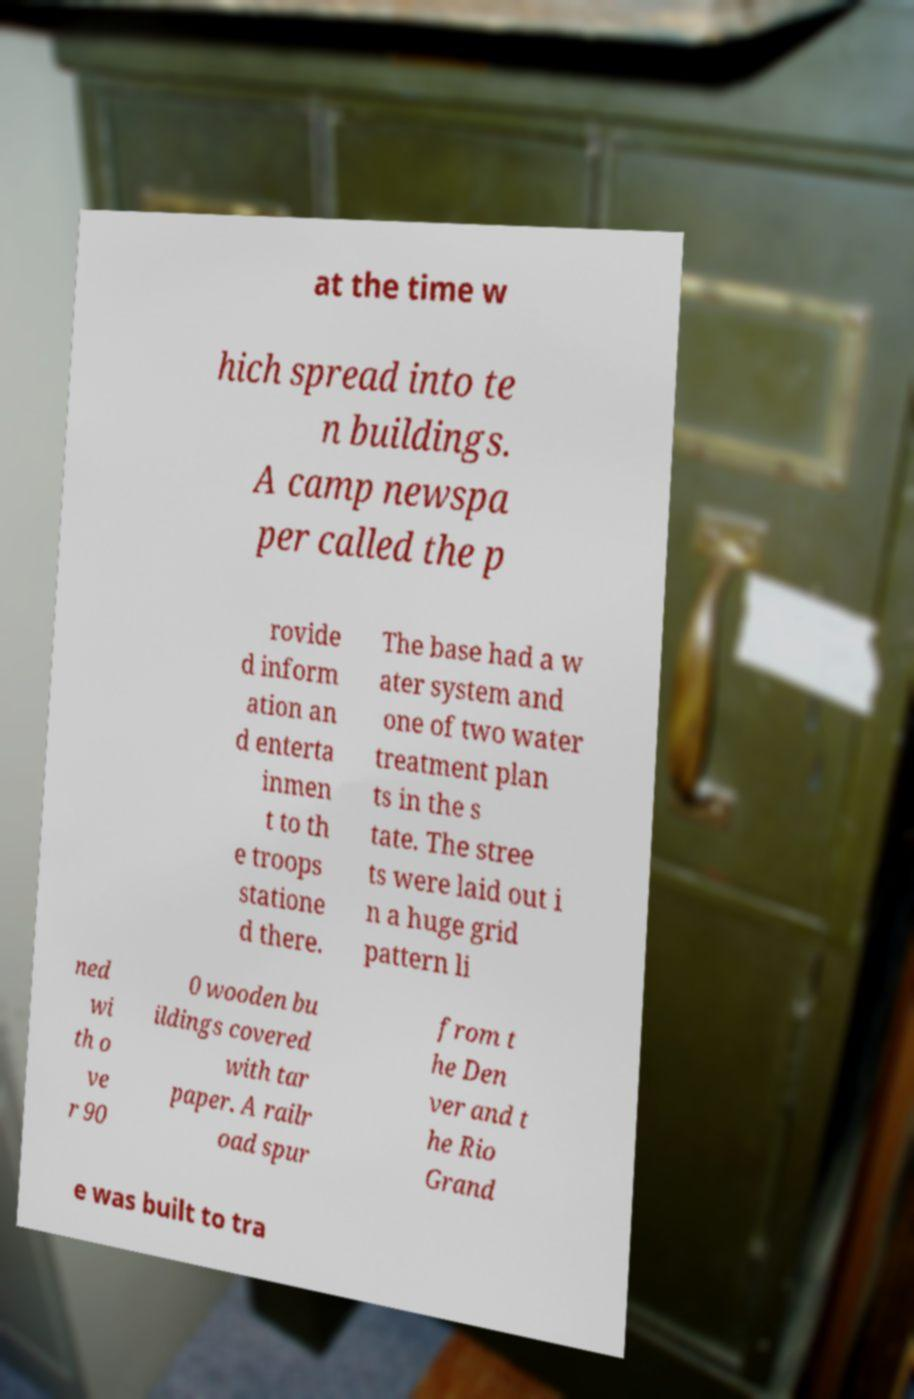Could you extract and type out the text from this image? at the time w hich spread into te n buildings. A camp newspa per called the p rovide d inform ation an d enterta inmen t to th e troops statione d there. The base had a w ater system and one of two water treatment plan ts in the s tate. The stree ts were laid out i n a huge grid pattern li ned wi th o ve r 90 0 wooden bu ildings covered with tar paper. A railr oad spur from t he Den ver and t he Rio Grand e was built to tra 